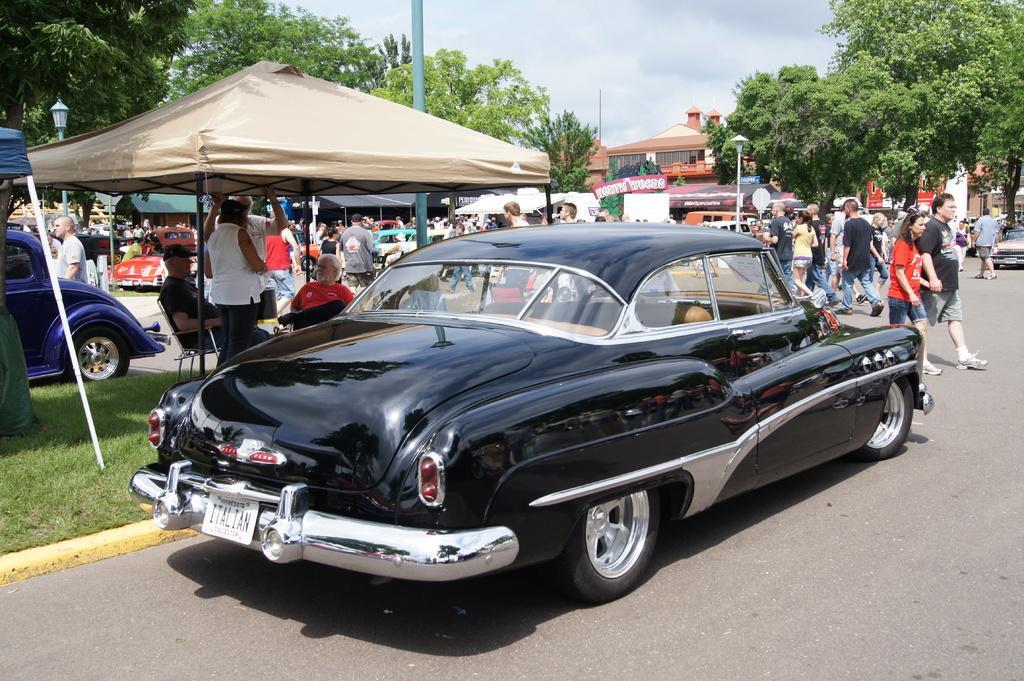Describe this image in one or two sentences. In the center of the image we can see cars on the road. In the background there are people walking and some of them are standing. There is a person sitting. On the left there is a tent. In the background there are sheds, trees, board and sky. 